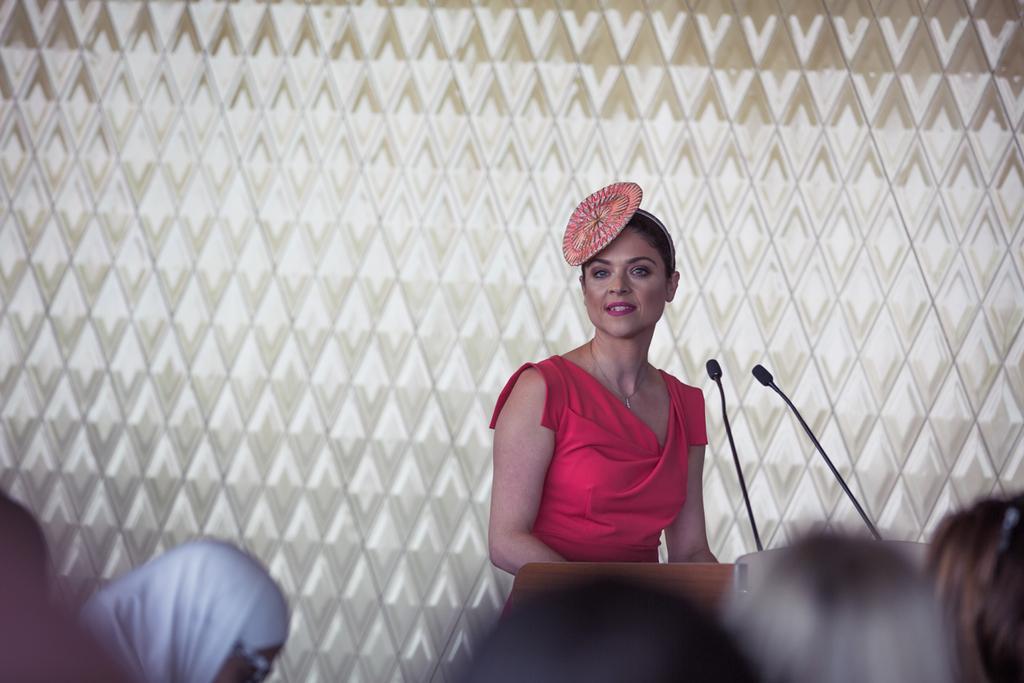In one or two sentences, can you explain what this image depicts? In the image there is a woman in red dress standing in front of dias, in the front there are many people, behind there is a wall. 